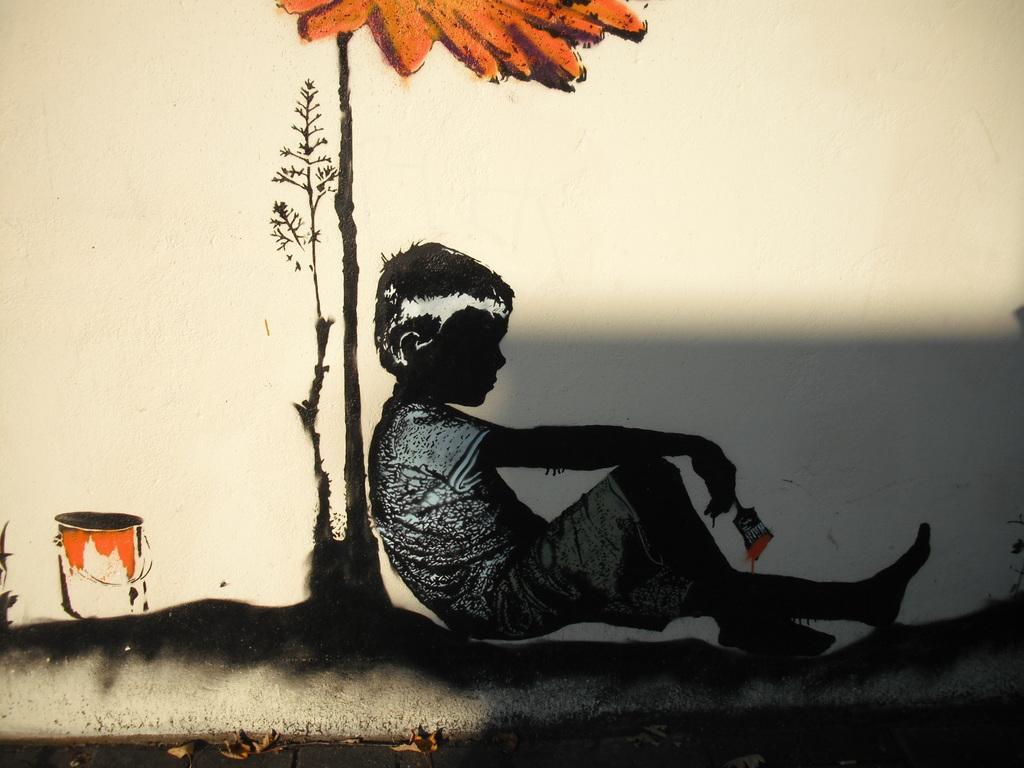How would you summarize this image in a sentence or two? In this image there is a painting. In the painting a kid is sitting holding a paint brush. Behind the kid there is a plant. Here is a bucket. 